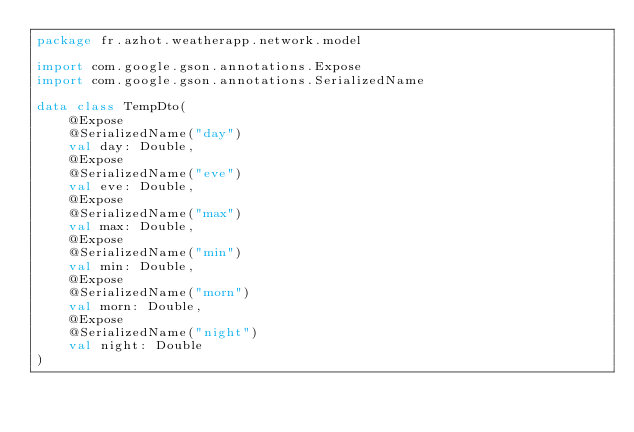Convert code to text. <code><loc_0><loc_0><loc_500><loc_500><_Kotlin_>package fr.azhot.weatherapp.network.model

import com.google.gson.annotations.Expose
import com.google.gson.annotations.SerializedName

data class TempDto(
    @Expose
    @SerializedName("day")
    val day: Double,
    @Expose
    @SerializedName("eve")
    val eve: Double,
    @Expose
    @SerializedName("max")
    val max: Double,
    @Expose
    @SerializedName("min")
    val min: Double,
    @Expose
    @SerializedName("morn")
    val morn: Double,
    @Expose
    @SerializedName("night")
    val night: Double
)</code> 